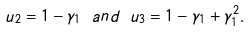<formula> <loc_0><loc_0><loc_500><loc_500>u _ { 2 } = 1 - \gamma _ { 1 } \ a n d \ u _ { 3 } = 1 - \gamma _ { 1 } + \gamma _ { 1 } ^ { 2 } .</formula> 